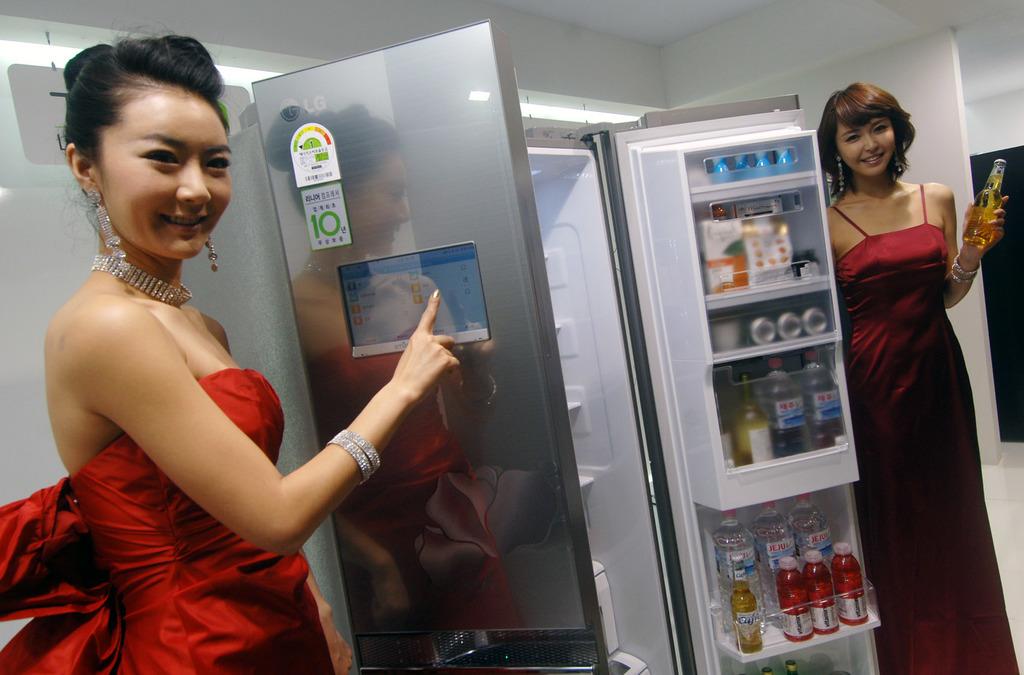Is this refrigerator energy star certified?
Give a very brief answer. Yes. What brand of television is this?
Offer a very short reply. Unanswerable. 